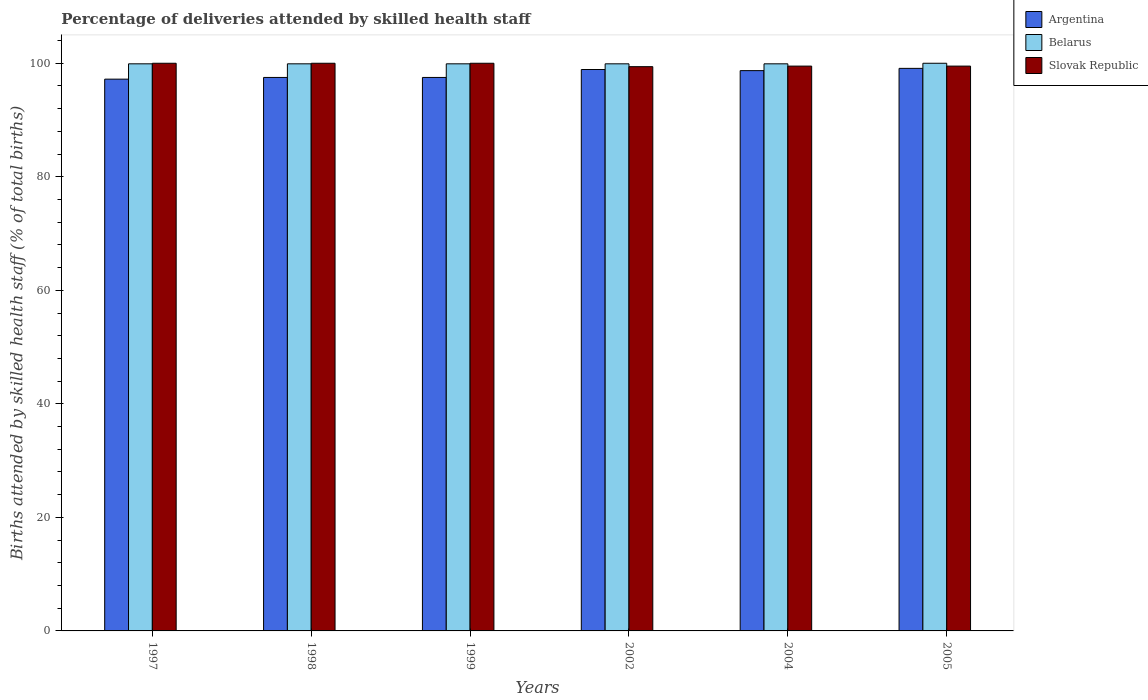How many bars are there on the 6th tick from the right?
Offer a very short reply. 3. What is the label of the 4th group of bars from the left?
Your response must be concise. 2002. In how many cases, is the number of bars for a given year not equal to the number of legend labels?
Provide a succinct answer. 0. What is the percentage of births attended by skilled health staff in Belarus in 2004?
Your answer should be very brief. 99.9. Across all years, what is the minimum percentage of births attended by skilled health staff in Belarus?
Make the answer very short. 99.9. In which year was the percentage of births attended by skilled health staff in Belarus minimum?
Provide a succinct answer. 1997. What is the total percentage of births attended by skilled health staff in Argentina in the graph?
Offer a very short reply. 588.9. What is the difference between the percentage of births attended by skilled health staff in Slovak Republic in 2004 and that in 2005?
Your answer should be very brief. 0. What is the difference between the percentage of births attended by skilled health staff in Argentina in 2005 and the percentage of births attended by skilled health staff in Belarus in 1997?
Your answer should be compact. -0.8. What is the average percentage of births attended by skilled health staff in Slovak Republic per year?
Ensure brevity in your answer.  99.73. In how many years, is the percentage of births attended by skilled health staff in Belarus greater than 4 %?
Give a very brief answer. 6. What is the ratio of the percentage of births attended by skilled health staff in Belarus in 2002 to that in 2005?
Ensure brevity in your answer.  1. Is the percentage of births attended by skilled health staff in Slovak Republic in 2004 less than that in 2005?
Offer a terse response. No. What is the difference between the highest and the lowest percentage of births attended by skilled health staff in Belarus?
Offer a terse response. 0.1. In how many years, is the percentage of births attended by skilled health staff in Argentina greater than the average percentage of births attended by skilled health staff in Argentina taken over all years?
Offer a very short reply. 3. What does the 3rd bar from the right in 1998 represents?
Provide a short and direct response. Argentina. How many years are there in the graph?
Your response must be concise. 6. What is the difference between two consecutive major ticks on the Y-axis?
Give a very brief answer. 20. Are the values on the major ticks of Y-axis written in scientific E-notation?
Give a very brief answer. No. Does the graph contain any zero values?
Make the answer very short. No. Where does the legend appear in the graph?
Your answer should be very brief. Top right. What is the title of the graph?
Your answer should be compact. Percentage of deliveries attended by skilled health staff. Does "Gabon" appear as one of the legend labels in the graph?
Provide a succinct answer. No. What is the label or title of the X-axis?
Your answer should be very brief. Years. What is the label or title of the Y-axis?
Provide a succinct answer. Births attended by skilled health staff (% of total births). What is the Births attended by skilled health staff (% of total births) in Argentina in 1997?
Offer a very short reply. 97.2. What is the Births attended by skilled health staff (% of total births) of Belarus in 1997?
Ensure brevity in your answer.  99.9. What is the Births attended by skilled health staff (% of total births) in Argentina in 1998?
Offer a terse response. 97.5. What is the Births attended by skilled health staff (% of total births) of Belarus in 1998?
Offer a terse response. 99.9. What is the Births attended by skilled health staff (% of total births) of Slovak Republic in 1998?
Ensure brevity in your answer.  100. What is the Births attended by skilled health staff (% of total births) in Argentina in 1999?
Your answer should be compact. 97.5. What is the Births attended by skilled health staff (% of total births) in Belarus in 1999?
Ensure brevity in your answer.  99.9. What is the Births attended by skilled health staff (% of total births) in Argentina in 2002?
Give a very brief answer. 98.9. What is the Births attended by skilled health staff (% of total births) in Belarus in 2002?
Keep it short and to the point. 99.9. What is the Births attended by skilled health staff (% of total births) of Slovak Republic in 2002?
Your response must be concise. 99.4. What is the Births attended by skilled health staff (% of total births) in Argentina in 2004?
Your answer should be compact. 98.7. What is the Births attended by skilled health staff (% of total births) in Belarus in 2004?
Make the answer very short. 99.9. What is the Births attended by skilled health staff (% of total births) in Slovak Republic in 2004?
Provide a short and direct response. 99.5. What is the Births attended by skilled health staff (% of total births) of Argentina in 2005?
Give a very brief answer. 99.1. What is the Births attended by skilled health staff (% of total births) of Belarus in 2005?
Ensure brevity in your answer.  100. What is the Births attended by skilled health staff (% of total births) of Slovak Republic in 2005?
Your response must be concise. 99.5. Across all years, what is the maximum Births attended by skilled health staff (% of total births) of Argentina?
Provide a short and direct response. 99.1. Across all years, what is the maximum Births attended by skilled health staff (% of total births) in Belarus?
Your response must be concise. 100. Across all years, what is the minimum Births attended by skilled health staff (% of total births) of Argentina?
Your answer should be very brief. 97.2. Across all years, what is the minimum Births attended by skilled health staff (% of total births) of Belarus?
Offer a very short reply. 99.9. Across all years, what is the minimum Births attended by skilled health staff (% of total births) in Slovak Republic?
Provide a succinct answer. 99.4. What is the total Births attended by skilled health staff (% of total births) of Argentina in the graph?
Your answer should be very brief. 588.9. What is the total Births attended by skilled health staff (% of total births) of Belarus in the graph?
Ensure brevity in your answer.  599.5. What is the total Births attended by skilled health staff (% of total births) of Slovak Republic in the graph?
Ensure brevity in your answer.  598.4. What is the difference between the Births attended by skilled health staff (% of total births) of Argentina in 1997 and that in 1998?
Give a very brief answer. -0.3. What is the difference between the Births attended by skilled health staff (% of total births) of Argentina in 1997 and that in 1999?
Provide a succinct answer. -0.3. What is the difference between the Births attended by skilled health staff (% of total births) in Belarus in 1997 and that in 1999?
Keep it short and to the point. 0. What is the difference between the Births attended by skilled health staff (% of total births) of Slovak Republic in 1997 and that in 1999?
Keep it short and to the point. 0. What is the difference between the Births attended by skilled health staff (% of total births) in Belarus in 1997 and that in 2004?
Offer a very short reply. 0. What is the difference between the Births attended by skilled health staff (% of total births) of Slovak Republic in 1997 and that in 2004?
Give a very brief answer. 0.5. What is the difference between the Births attended by skilled health staff (% of total births) of Argentina in 1997 and that in 2005?
Ensure brevity in your answer.  -1.9. What is the difference between the Births attended by skilled health staff (% of total births) of Slovak Republic in 1997 and that in 2005?
Make the answer very short. 0.5. What is the difference between the Births attended by skilled health staff (% of total births) in Argentina in 1998 and that in 1999?
Give a very brief answer. 0. What is the difference between the Births attended by skilled health staff (% of total births) in Belarus in 1998 and that in 1999?
Give a very brief answer. 0. What is the difference between the Births attended by skilled health staff (% of total births) of Slovak Republic in 1998 and that in 1999?
Give a very brief answer. 0. What is the difference between the Births attended by skilled health staff (% of total births) of Slovak Republic in 1998 and that in 2002?
Offer a terse response. 0.6. What is the difference between the Births attended by skilled health staff (% of total births) in Argentina in 1998 and that in 2004?
Your answer should be compact. -1.2. What is the difference between the Births attended by skilled health staff (% of total births) of Argentina in 1998 and that in 2005?
Provide a succinct answer. -1.6. What is the difference between the Births attended by skilled health staff (% of total births) in Slovak Republic in 1998 and that in 2005?
Your response must be concise. 0.5. What is the difference between the Births attended by skilled health staff (% of total births) of Argentina in 1999 and that in 2002?
Provide a succinct answer. -1.4. What is the difference between the Births attended by skilled health staff (% of total births) in Argentina in 1999 and that in 2004?
Your answer should be compact. -1.2. What is the difference between the Births attended by skilled health staff (% of total births) in Belarus in 1999 and that in 2004?
Your answer should be very brief. 0. What is the difference between the Births attended by skilled health staff (% of total births) in Slovak Republic in 1999 and that in 2005?
Offer a very short reply. 0.5. What is the difference between the Births attended by skilled health staff (% of total births) in Belarus in 2002 and that in 2004?
Make the answer very short. 0. What is the difference between the Births attended by skilled health staff (% of total births) in Argentina in 2002 and that in 2005?
Provide a succinct answer. -0.2. What is the difference between the Births attended by skilled health staff (% of total births) in Slovak Republic in 2002 and that in 2005?
Give a very brief answer. -0.1. What is the difference between the Births attended by skilled health staff (% of total births) of Belarus in 2004 and that in 2005?
Provide a short and direct response. -0.1. What is the difference between the Births attended by skilled health staff (% of total births) of Slovak Republic in 2004 and that in 2005?
Provide a succinct answer. 0. What is the difference between the Births attended by skilled health staff (% of total births) of Argentina in 1997 and the Births attended by skilled health staff (% of total births) of Belarus in 1998?
Give a very brief answer. -2.7. What is the difference between the Births attended by skilled health staff (% of total births) of Belarus in 1997 and the Births attended by skilled health staff (% of total births) of Slovak Republic in 1998?
Give a very brief answer. -0.1. What is the difference between the Births attended by skilled health staff (% of total births) in Belarus in 1997 and the Births attended by skilled health staff (% of total births) in Slovak Republic in 1999?
Your response must be concise. -0.1. What is the difference between the Births attended by skilled health staff (% of total births) in Argentina in 1997 and the Births attended by skilled health staff (% of total births) in Slovak Republic in 2002?
Offer a terse response. -2.2. What is the difference between the Births attended by skilled health staff (% of total births) of Argentina in 1997 and the Births attended by skilled health staff (% of total births) of Belarus in 2004?
Give a very brief answer. -2.7. What is the difference between the Births attended by skilled health staff (% of total births) of Argentina in 1997 and the Births attended by skilled health staff (% of total births) of Slovak Republic in 2004?
Offer a terse response. -2.3. What is the difference between the Births attended by skilled health staff (% of total births) in Belarus in 1997 and the Births attended by skilled health staff (% of total births) in Slovak Republic in 2004?
Make the answer very short. 0.4. What is the difference between the Births attended by skilled health staff (% of total births) of Argentina in 1998 and the Births attended by skilled health staff (% of total births) of Slovak Republic in 1999?
Provide a succinct answer. -2.5. What is the difference between the Births attended by skilled health staff (% of total births) in Belarus in 1998 and the Births attended by skilled health staff (% of total births) in Slovak Republic in 1999?
Give a very brief answer. -0.1. What is the difference between the Births attended by skilled health staff (% of total births) of Argentina in 1998 and the Births attended by skilled health staff (% of total births) of Slovak Republic in 2002?
Keep it short and to the point. -1.9. What is the difference between the Births attended by skilled health staff (% of total births) in Argentina in 1998 and the Births attended by skilled health staff (% of total births) in Belarus in 2004?
Provide a succinct answer. -2.4. What is the difference between the Births attended by skilled health staff (% of total births) in Argentina in 1998 and the Births attended by skilled health staff (% of total births) in Slovak Republic in 2004?
Make the answer very short. -2. What is the difference between the Births attended by skilled health staff (% of total births) in Argentina in 1998 and the Births attended by skilled health staff (% of total births) in Belarus in 2005?
Your answer should be very brief. -2.5. What is the difference between the Births attended by skilled health staff (% of total births) of Belarus in 1998 and the Births attended by skilled health staff (% of total births) of Slovak Republic in 2005?
Provide a succinct answer. 0.4. What is the difference between the Births attended by skilled health staff (% of total births) of Argentina in 1999 and the Births attended by skilled health staff (% of total births) of Belarus in 2002?
Provide a succinct answer. -2.4. What is the difference between the Births attended by skilled health staff (% of total births) in Argentina in 1999 and the Births attended by skilled health staff (% of total births) in Slovak Republic in 2002?
Provide a short and direct response. -1.9. What is the difference between the Births attended by skilled health staff (% of total births) in Belarus in 1999 and the Births attended by skilled health staff (% of total births) in Slovak Republic in 2002?
Offer a terse response. 0.5. What is the difference between the Births attended by skilled health staff (% of total births) in Belarus in 1999 and the Births attended by skilled health staff (% of total births) in Slovak Republic in 2004?
Give a very brief answer. 0.4. What is the difference between the Births attended by skilled health staff (% of total births) in Argentina in 1999 and the Births attended by skilled health staff (% of total births) in Belarus in 2005?
Your answer should be compact. -2.5. What is the difference between the Births attended by skilled health staff (% of total births) in Belarus in 1999 and the Births attended by skilled health staff (% of total births) in Slovak Republic in 2005?
Keep it short and to the point. 0.4. What is the difference between the Births attended by skilled health staff (% of total births) of Argentina in 2002 and the Births attended by skilled health staff (% of total births) of Belarus in 2004?
Your answer should be very brief. -1. What is the difference between the Births attended by skilled health staff (% of total births) in Argentina in 2002 and the Births attended by skilled health staff (% of total births) in Slovak Republic in 2004?
Give a very brief answer. -0.6. What is the difference between the Births attended by skilled health staff (% of total births) of Belarus in 2002 and the Births attended by skilled health staff (% of total births) of Slovak Republic in 2005?
Offer a very short reply. 0.4. What is the difference between the Births attended by skilled health staff (% of total births) in Argentina in 2004 and the Births attended by skilled health staff (% of total births) in Slovak Republic in 2005?
Provide a short and direct response. -0.8. What is the difference between the Births attended by skilled health staff (% of total births) of Belarus in 2004 and the Births attended by skilled health staff (% of total births) of Slovak Republic in 2005?
Your answer should be very brief. 0.4. What is the average Births attended by skilled health staff (% of total births) in Argentina per year?
Keep it short and to the point. 98.15. What is the average Births attended by skilled health staff (% of total births) in Belarus per year?
Offer a very short reply. 99.92. What is the average Births attended by skilled health staff (% of total births) in Slovak Republic per year?
Provide a short and direct response. 99.73. In the year 1998, what is the difference between the Births attended by skilled health staff (% of total births) of Argentina and Births attended by skilled health staff (% of total births) of Belarus?
Offer a very short reply. -2.4. In the year 1998, what is the difference between the Births attended by skilled health staff (% of total births) in Argentina and Births attended by skilled health staff (% of total births) in Slovak Republic?
Offer a very short reply. -2.5. In the year 1999, what is the difference between the Births attended by skilled health staff (% of total births) in Argentina and Births attended by skilled health staff (% of total births) in Belarus?
Offer a very short reply. -2.4. In the year 2002, what is the difference between the Births attended by skilled health staff (% of total births) in Argentina and Births attended by skilled health staff (% of total births) in Belarus?
Provide a short and direct response. -1. In the year 2002, what is the difference between the Births attended by skilled health staff (% of total births) in Argentina and Births attended by skilled health staff (% of total births) in Slovak Republic?
Make the answer very short. -0.5. In the year 2002, what is the difference between the Births attended by skilled health staff (% of total births) of Belarus and Births attended by skilled health staff (% of total births) of Slovak Republic?
Your answer should be very brief. 0.5. In the year 2004, what is the difference between the Births attended by skilled health staff (% of total births) of Belarus and Births attended by skilled health staff (% of total births) of Slovak Republic?
Make the answer very short. 0.4. In the year 2005, what is the difference between the Births attended by skilled health staff (% of total births) of Argentina and Births attended by skilled health staff (% of total births) of Slovak Republic?
Your response must be concise. -0.4. In the year 2005, what is the difference between the Births attended by skilled health staff (% of total births) in Belarus and Births attended by skilled health staff (% of total births) in Slovak Republic?
Keep it short and to the point. 0.5. What is the ratio of the Births attended by skilled health staff (% of total births) in Belarus in 1997 to that in 1998?
Keep it short and to the point. 1. What is the ratio of the Births attended by skilled health staff (% of total births) in Argentina in 1997 to that in 1999?
Ensure brevity in your answer.  1. What is the ratio of the Births attended by skilled health staff (% of total births) of Belarus in 1997 to that in 1999?
Offer a terse response. 1. What is the ratio of the Births attended by skilled health staff (% of total births) of Slovak Republic in 1997 to that in 1999?
Provide a succinct answer. 1. What is the ratio of the Births attended by skilled health staff (% of total births) in Argentina in 1997 to that in 2002?
Your answer should be very brief. 0.98. What is the ratio of the Births attended by skilled health staff (% of total births) in Slovak Republic in 1997 to that in 2002?
Your response must be concise. 1.01. What is the ratio of the Births attended by skilled health staff (% of total births) of Argentina in 1997 to that in 2004?
Provide a short and direct response. 0.98. What is the ratio of the Births attended by skilled health staff (% of total births) of Slovak Republic in 1997 to that in 2004?
Give a very brief answer. 1. What is the ratio of the Births attended by skilled health staff (% of total births) of Argentina in 1997 to that in 2005?
Provide a succinct answer. 0.98. What is the ratio of the Births attended by skilled health staff (% of total births) of Belarus in 1997 to that in 2005?
Keep it short and to the point. 1. What is the ratio of the Births attended by skilled health staff (% of total births) in Belarus in 1998 to that in 1999?
Offer a terse response. 1. What is the ratio of the Births attended by skilled health staff (% of total births) in Slovak Republic in 1998 to that in 1999?
Offer a terse response. 1. What is the ratio of the Births attended by skilled health staff (% of total births) in Argentina in 1998 to that in 2002?
Your answer should be very brief. 0.99. What is the ratio of the Births attended by skilled health staff (% of total births) in Argentina in 1998 to that in 2004?
Your answer should be very brief. 0.99. What is the ratio of the Births attended by skilled health staff (% of total births) in Argentina in 1998 to that in 2005?
Your answer should be compact. 0.98. What is the ratio of the Births attended by skilled health staff (% of total births) of Slovak Republic in 1998 to that in 2005?
Keep it short and to the point. 1. What is the ratio of the Births attended by skilled health staff (% of total births) in Argentina in 1999 to that in 2002?
Make the answer very short. 0.99. What is the ratio of the Births attended by skilled health staff (% of total births) in Belarus in 1999 to that in 2002?
Give a very brief answer. 1. What is the ratio of the Births attended by skilled health staff (% of total births) in Slovak Republic in 1999 to that in 2002?
Your answer should be very brief. 1.01. What is the ratio of the Births attended by skilled health staff (% of total births) of Belarus in 1999 to that in 2004?
Your response must be concise. 1. What is the ratio of the Births attended by skilled health staff (% of total births) in Slovak Republic in 1999 to that in 2004?
Give a very brief answer. 1. What is the ratio of the Births attended by skilled health staff (% of total births) in Argentina in 1999 to that in 2005?
Provide a succinct answer. 0.98. What is the ratio of the Births attended by skilled health staff (% of total births) in Argentina in 2002 to that in 2004?
Provide a succinct answer. 1. What is the ratio of the Births attended by skilled health staff (% of total births) in Belarus in 2002 to that in 2004?
Your response must be concise. 1. What is the ratio of the Births attended by skilled health staff (% of total births) in Slovak Republic in 2002 to that in 2004?
Make the answer very short. 1. What is the ratio of the Births attended by skilled health staff (% of total births) in Slovak Republic in 2004 to that in 2005?
Your response must be concise. 1. What is the difference between the highest and the second highest Births attended by skilled health staff (% of total births) in Belarus?
Make the answer very short. 0.1. What is the difference between the highest and the lowest Births attended by skilled health staff (% of total births) in Argentina?
Make the answer very short. 1.9. What is the difference between the highest and the lowest Births attended by skilled health staff (% of total births) in Slovak Republic?
Provide a short and direct response. 0.6. 